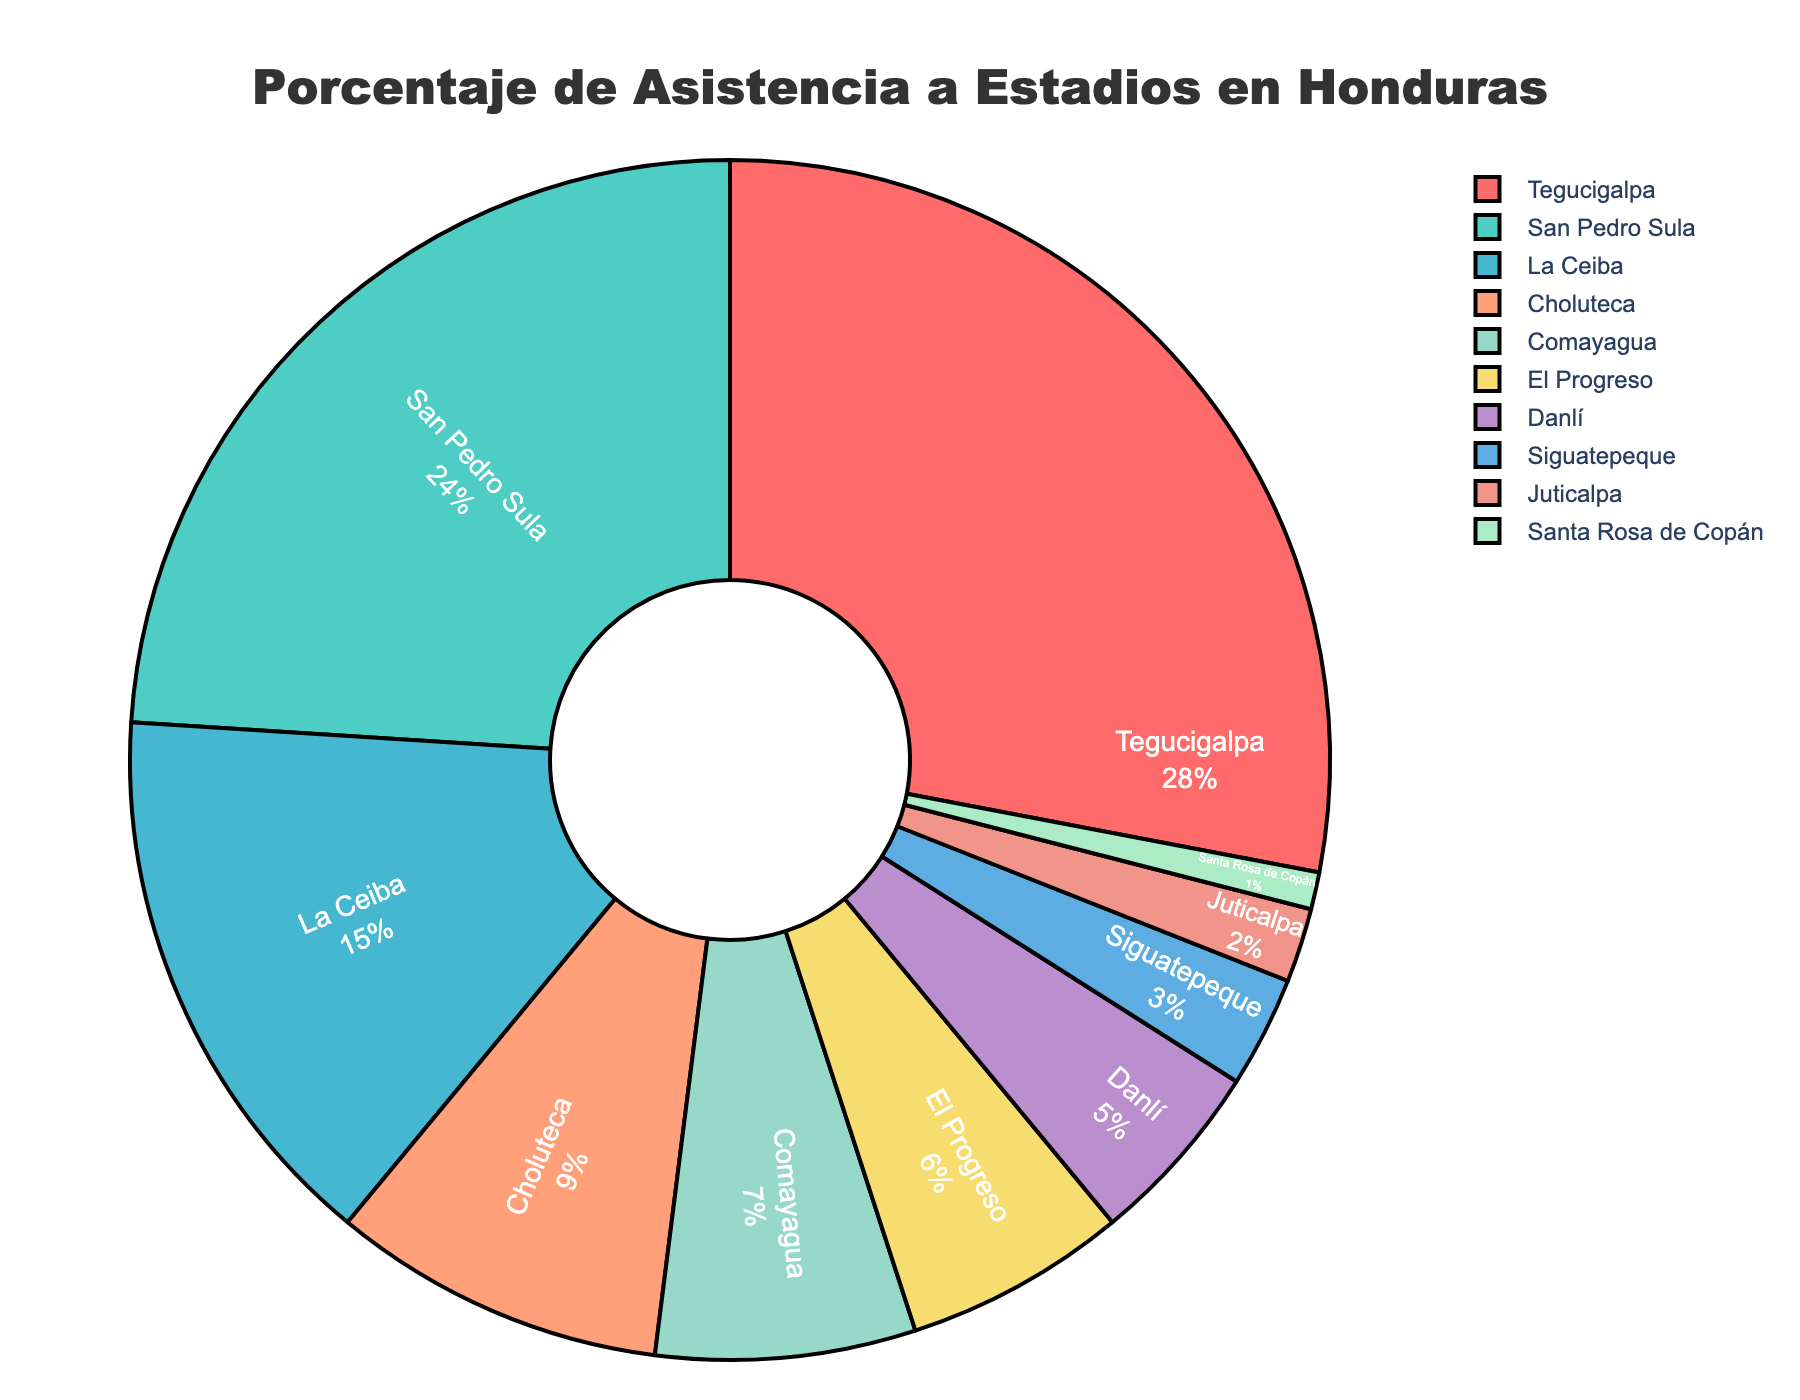¿Qué ciudad tiene el mayor porcentaje de asistencia a estadios? Al observar el gráfico, Tegucigalpa tiene el segmento más grande del pastel, lo que indica que tiene el mayor porcentaje de asistencia.
Answer: Tegucigalpa ¿Cuál es la diferencia en el porcentaje de asistencia entre Tegucigalpa y San Pedro Sula? Tegucigalpa tiene un 28% de asistencia y San Pedro Sula tiene un 24%. Restando estos dos porcentajes, obtenemos 28% - 24% = 4%.
Answer: 4% ¿Cuáles tres ciudades tienen los porcentajes de asistencia más bajos? Observando los segmentos más pequeños del gráfico, las tres ciudades con los porcentajes más bajos son Santa Rosa de Copán (1%), Juticalpa (2%) y Siguatepeque (3%).
Answer: Santa Rosa de Copán, Juticalpa y Siguatepeque ¿Cuál es el porcentaje total de asistencia en las tres ciudades con mayor asistencia? Las tres ciudades con mayor asistencia son Tegucigalpa (28%), San Pedro Sula (24%) y La Ceiba (15%). Sumando estos porcentajes, obtenemos 28% + 24% + 15% = 67%.
Answer: 67% ¿Es mayor el porcentaje de asistencia en Choluteca o en Comayagua? Al comparar ambos segmentos en el gráfico, vemos que Choluteca tiene un 9% y Comayagua un 7%, lo cual indica que Choluteca tiene un porcentaje mayor.
Answer: Choluteca ¿Cuál es el porcentaje combinado de asistencia en El Progreso, Danlí y Siguatepeque? Sumando los porcentajes individuales: El Progreso (6%), Danlí (5%) y Siguatepeque (3%). La suma es 6% + 5% + 3% = 14%.
Answer: 14% ¿Cuál es la diferencia en porcentaje de asistencia entre La Ceiba y las ciudades con menor asistencia combinadas (Juticalpa y Santa Rosa de Copán)? La Ceiba tiene un 15% de asistencia. Juticalpa (2%) y Santa Rosa de Copán (1%) combinadas tienen un 3%. La diferencia es 15% - 3% = 12%.
Answer: 12% ¿Cuál es el porcentaje de asistencia en Tegucigalpa en relación al total de asistencia? El total del gráfico representa el 100%. Tegucigalpa tiene un 28%, por lo que 28% del total se refiere a Tegucigalpa.
Answer: 28% ¿Qué ciudad ocupa el sexto lugar en términos de porcentaje de asistencia? Mirando de mayor a menor, el orden es: Tegucigalpa (28%), San Pedro Sula (24%), La Ceiba (15%), Choluteca (9%), Comayagua (7%), y El Progreso (6%).
Answer: El Progreso ¿Cuál es el porcentaje total de asistencia en las ciudades que tienen menos del 10% cada una? Las ciudades que tienen menos del 10% son: Comayagua (7%), El Progreso (6%), Danlí (5%), Siguatepeque (3%), Juticalpa (2%) y Santa Rosa de Copán (1%). Sumando estos porcentajes, obtenemos 7% + 6% + 5% + 3% + 2% + 1% = 24%.
Answer: 24% 